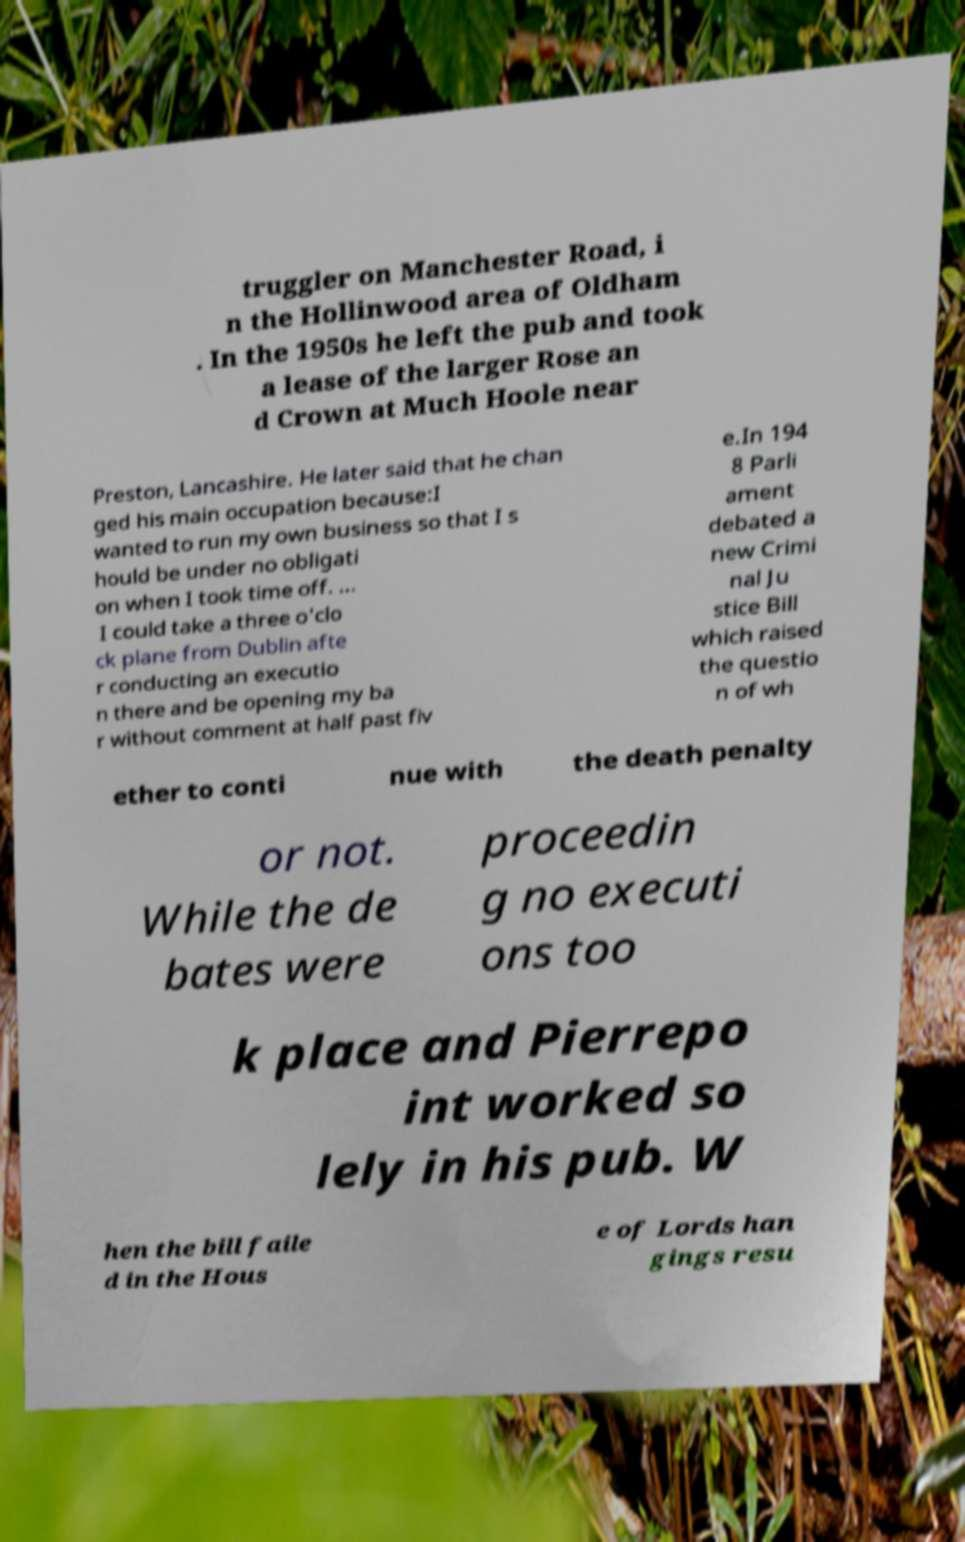I need the written content from this picture converted into text. Can you do that? truggler on Manchester Road, i n the Hollinwood area of Oldham . In the 1950s he left the pub and took a lease of the larger Rose an d Crown at Much Hoole near Preston, Lancashire. He later said that he chan ged his main occupation because:I wanted to run my own business so that I s hould be under no obligati on when I took time off. ... I could take a three o'clo ck plane from Dublin afte r conducting an executio n there and be opening my ba r without comment at half past fiv e.In 194 8 Parli ament debated a new Crimi nal Ju stice Bill which raised the questio n of wh ether to conti nue with the death penalty or not. While the de bates were proceedin g no executi ons too k place and Pierrepo int worked so lely in his pub. W hen the bill faile d in the Hous e of Lords han gings resu 